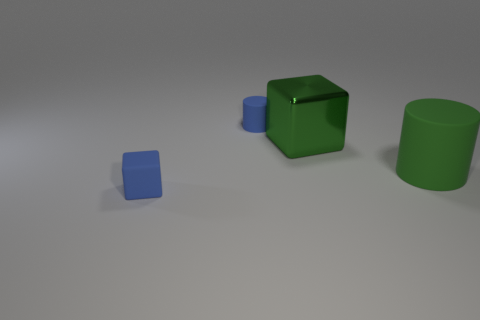Add 1 small yellow cubes. How many objects exist? 5 Subtract 1 blue cylinders. How many objects are left? 3 Subtract all tiny blue matte blocks. Subtract all rubber blocks. How many objects are left? 2 Add 1 shiny objects. How many shiny objects are left? 2 Add 3 small yellow matte cylinders. How many small yellow matte cylinders exist? 3 